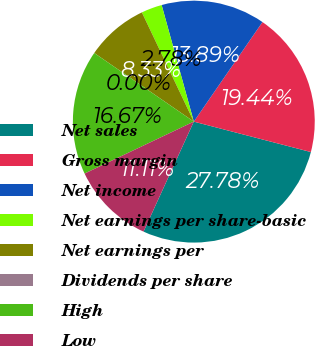Convert chart. <chart><loc_0><loc_0><loc_500><loc_500><pie_chart><fcel>Net sales<fcel>Gross margin<fcel>Net income<fcel>Net earnings per share-basic<fcel>Net earnings per<fcel>Dividends per share<fcel>High<fcel>Low<nl><fcel>27.78%<fcel>19.44%<fcel>13.89%<fcel>2.78%<fcel>8.33%<fcel>0.0%<fcel>16.67%<fcel>11.11%<nl></chart> 